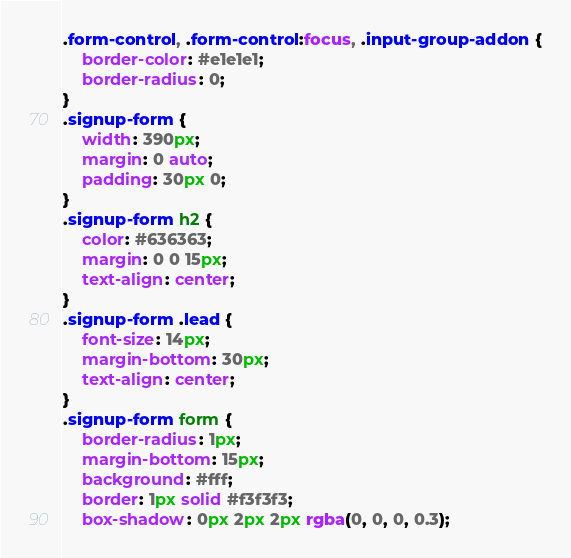Convert code to text. <code><loc_0><loc_0><loc_500><loc_500><_CSS_>
.form-control, .form-control:focus, .input-group-addon {
    border-color: #e1e1e1;
    border-radius: 0;
}
.signup-form {
    width: 390px;
    margin: 0 auto;
    padding: 30px 0;
}
.signup-form h2 {
    color: #636363;
    margin: 0 0 15px;
    text-align: center;
}
.signup-form .lead {
    font-size: 14px;
    margin-bottom: 30px;
    text-align: center;
}
.signup-form form {		
    border-radius: 1px;
    margin-bottom: 15px;
    background: #fff;
    border: 1px solid #f3f3f3;
    box-shadow: 0px 2px 2px rgba(0, 0, 0, 0.3);</code> 